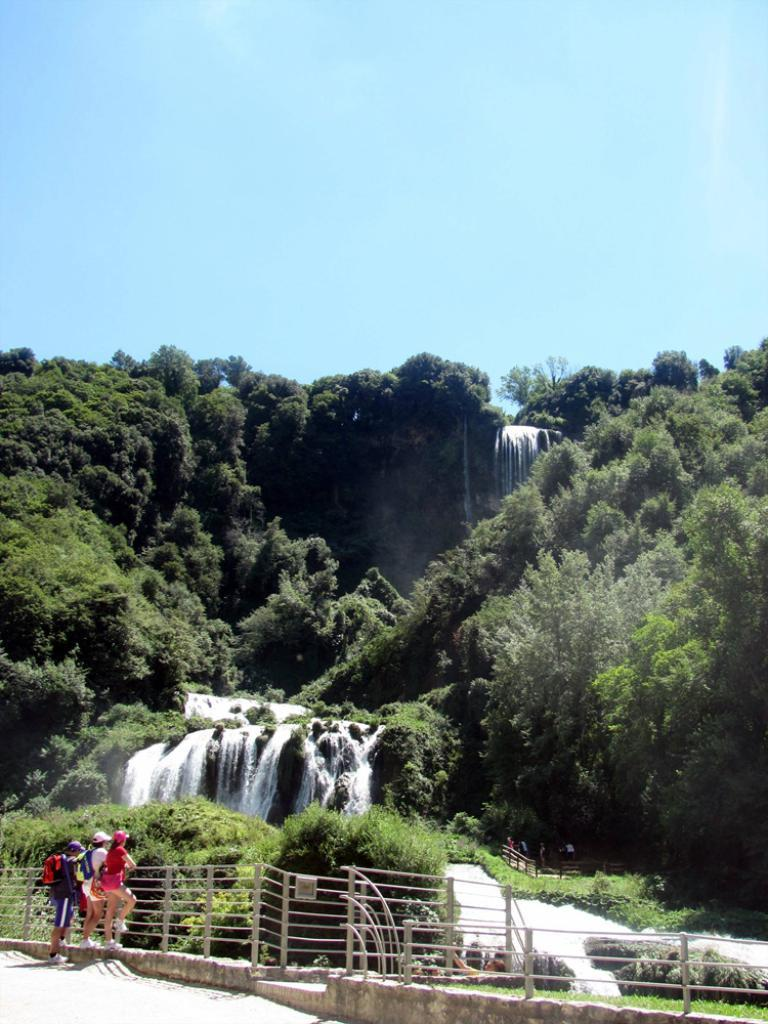How many people are in the image? There are three persons standing in the left corner of the image. What is in front of the persons? There is a fence in front of the persons. What can be seen in the background of the image? There is a waterfall and trees in the background of the image. What are the persons talking about while drinking with their friends in the image? There is no indication in the image that the persons are talking or drinking, nor are there any friends present. 